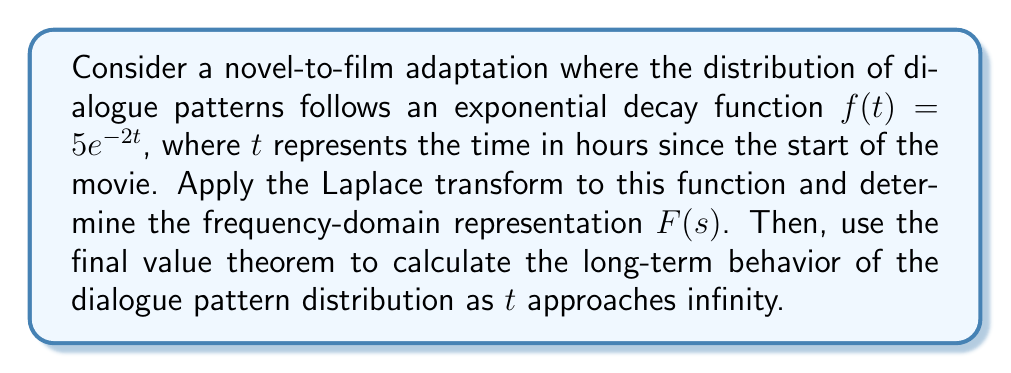Could you help me with this problem? To solve this problem, we'll follow these steps:

1) Apply the Laplace transform to the given function.
2) Simplify the resulting expression to find $F(s)$.
3) Use the final value theorem to determine the long-term behavior.

Step 1: Applying the Laplace transform

The Laplace transform of $f(t) = 5e^{-2t}$ is given by:

$$\mathcal{L}\{f(t)\} = \int_0^\infty 5e^{-2t}e^{-st}dt$$

Step 2: Simplifying to find $F(s)$

$$\begin{align}
F(s) &= 5\int_0^\infty e^{-(s+2)t}dt \\
&= 5\left[-\frac{1}{s+2}e^{-(s+2)t}\right]_0^\infty \\
&= 5\left[0 - \left(-\frac{1}{s+2}\right)\right] \\
&= \frac{5}{s+2}
\end{align}$$

Step 3: Using the final value theorem

The final value theorem states that:

$$\lim_{t \to \infty} f(t) = \lim_{s \to 0} sF(s)$$

Applying this to our $F(s)$:

$$\begin{align}
\lim_{t \to \infty} f(t) &= \lim_{s \to 0} s\frac{5}{s+2} \\
&= \lim_{s \to 0} \frac{5s}{s+2} \\
&= \frac{5 \cdot 0}{0+2} \\
&= 0
\end{align}$$

This result indicates that the dialogue pattern distribution approaches zero as time goes to infinity, which aligns with the exponential decay nature of the original function.
Answer: The Laplace transform of $f(t) = 5e^{-2t}$ is $F(s) = \frac{5}{s+2}$. The long-term behavior of the dialogue pattern distribution as $t$ approaches infinity is 0. 